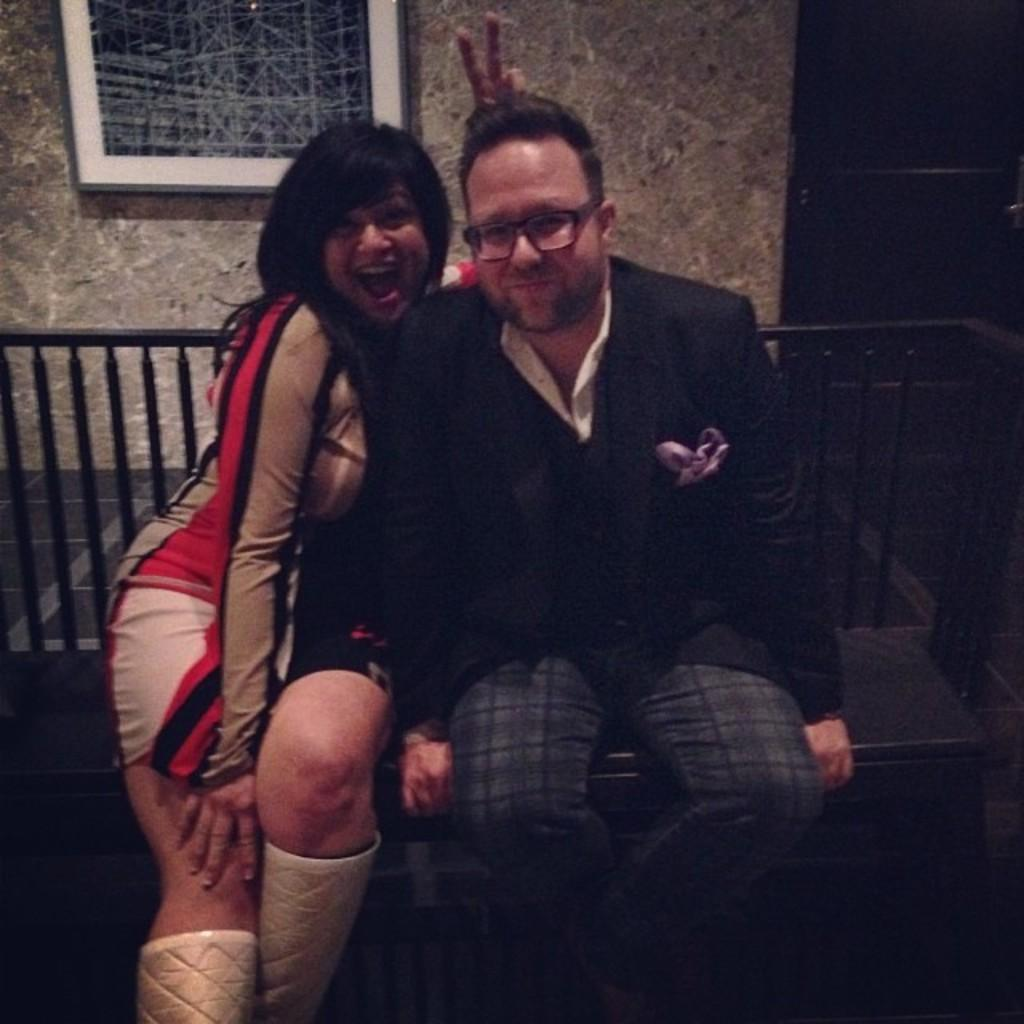How many people are sitting on the bench in the image? There are two persons sitting on a bench in the image. What can be seen near the bench? There is a railing in the image. What is hanging on the wall in the image? There is a photo frame on a wall in the image. What architectural feature is present in the image? There is a door in the image. What type of fruit is hanging from the railing in the image? There is no fruit hanging from the railing in the image. Is there a scarf draped over the door in the image? There is no mention of a scarf in the image, so it cannot be determined if one is draped over the door. 